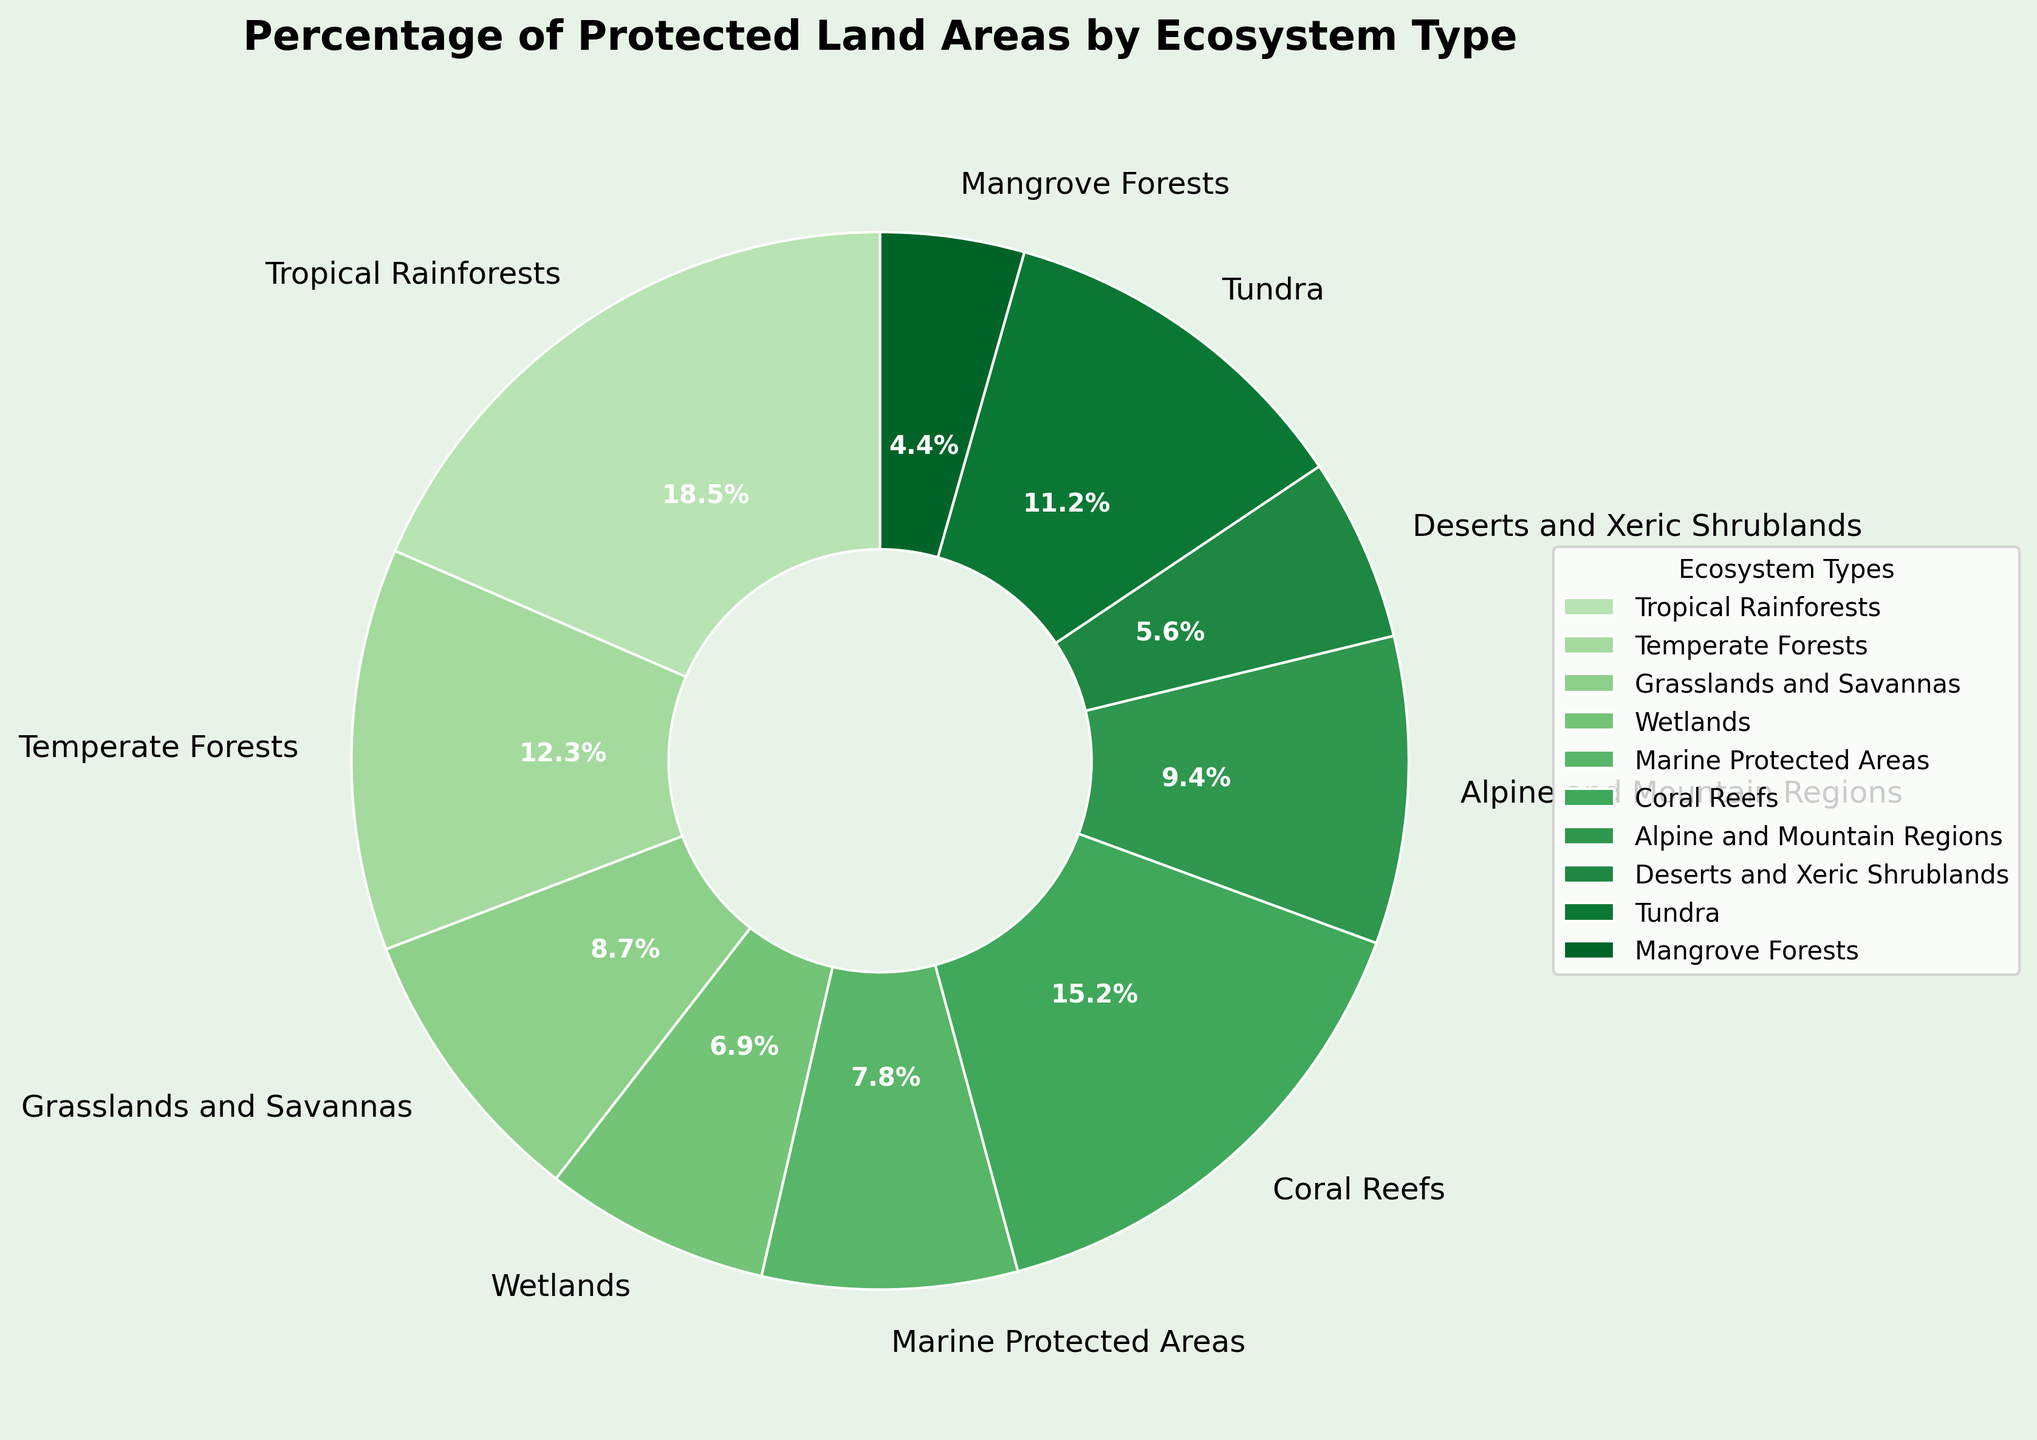Which ecosystem type has the highest percentage of protected land areas? Tropical Rainforests. Look for the largest slice in the pie chart, which is Tropical Rainforests at 18.5%.
Answer: Tropical Rainforests Which ecosystem type has the lowest percentage of protected land areas? Mangrove Forests. Identify the smallest slice, which shows 4.4%.
Answer: Mangrove Forests What is the combined percentage of protected land areas for Grasslands and Savannas and Deserts and Xeric Shrublands? Add the percentages of Grasslands and Savannas (8.7%) and Deserts and Xeric Shrublands (5.6%). \( 8.7 + 5.6 = 14.3 \)
Answer: 14.3% Which ecosystem types have a percentage of protected land areas greater than 10%? Tropical Rainforests (18.5%), Temperate Forests (12.3%), Coral Reefs (15.2%), and Tundra (11.2%). Identify slices with values above 10%.
Answer: Tropical Rainforests, Temperate Forests, Coral Reefs, Tundra How does the percentage of protected land areas for Marine Protected Areas compare to that for Wetlands? The slice for Marine Protected Areas is labeled 7.8%, while Wetlands is 6.9%. \( 7.8 > 6.9 \)
Answer: Marine Protected Areas > Wetlands What is the average percentage of protected land areas for ecosystems with percentages between 5% and 10%? Calculate the average of Grasslands and Savannas (8.7%), Marine Protected Areas (7.8%), Alpine and Mountain Regions (9.4%), and Deserts and Xeric Shrublands (5.6%). Sum these percentages and divide by 4: \[(8.7+7.8+9.4+5.6)/4 = 31.5/4 = 7.875\]
Answer: 7.88% Are there more protected land areas in Coral Reefs or Alpine and Mountain Regions? Compare the percentages: Coral Reefs (15.2%) and Alpine and Mountain Regions (9.4%). \( 15.2 > 9.4 \)
Answer: Coral Reefs Which two ecosystem types combined have a percentage of protected land areas close to that of Tropical Rainforests? Coral Reefs (15.2%) and Mangrove Forests (4.4%). Summing these two: \( 15.2 + 4.4 = 19.6 \), which is close to Tropical Rainforests (18.5%).
Answer: Coral Reefs and Mangrove Forests What's the total percentage of protected land areas covered by ecosystems with percentages under 7%? Sum the percentages of Wetlands (6.9%) + Deserts and Xeric Shrublands (5.6%) + Mangrove Forests (4.4%): \( 6.9 + 5.6 + 4.4 = 16.9 \)
Answer: 16.9% 